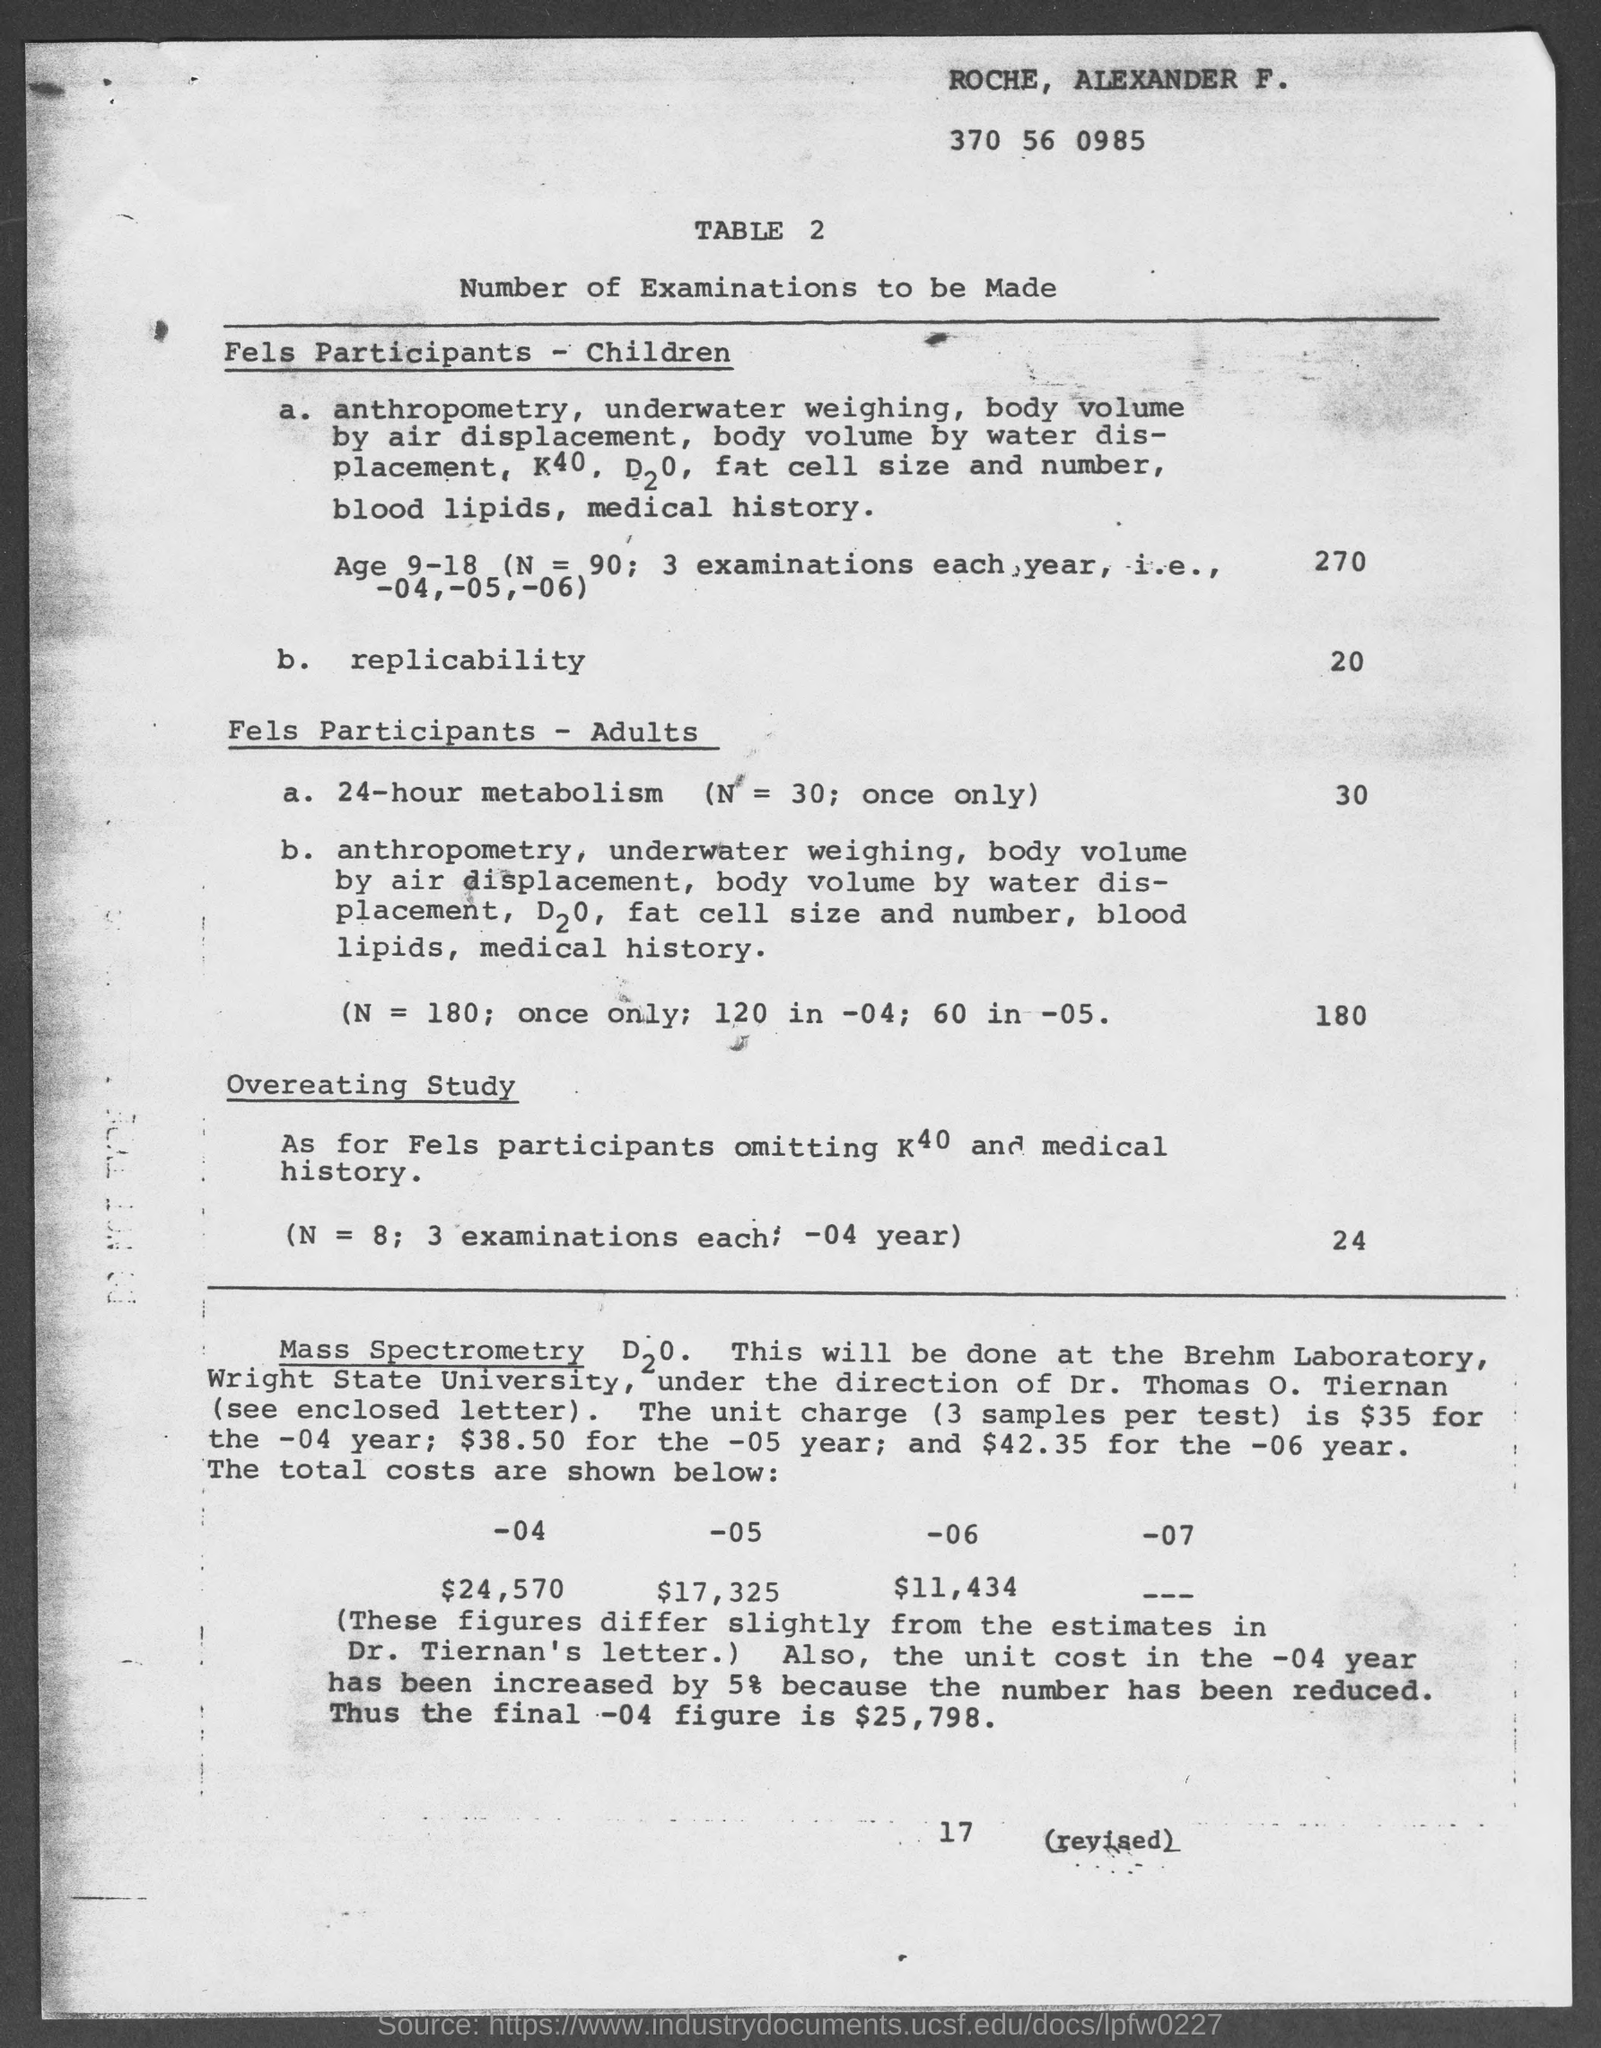Who's name written in the top of the document?
Give a very brief answer. Roche, Alexander F. What is the Table  number ?
Your response must be concise. 2. 